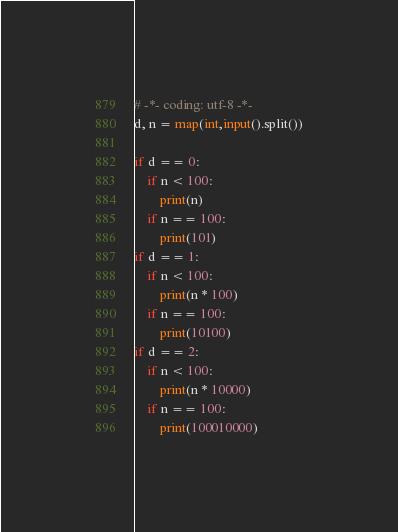Convert code to text. <code><loc_0><loc_0><loc_500><loc_500><_Python_># -*- coding: utf-8 -*-
d, n = map(int,input().split())

if d == 0:
    if n < 100:
        print(n)
    if n == 100:
        print(101)
if d == 1:
    if n < 100:
        print(n * 100)
    if n == 100:
        print(10100)
if d == 2:
    if n < 100:
        print(n * 10000)
    if n == 100:
        print(100010000)
</code> 